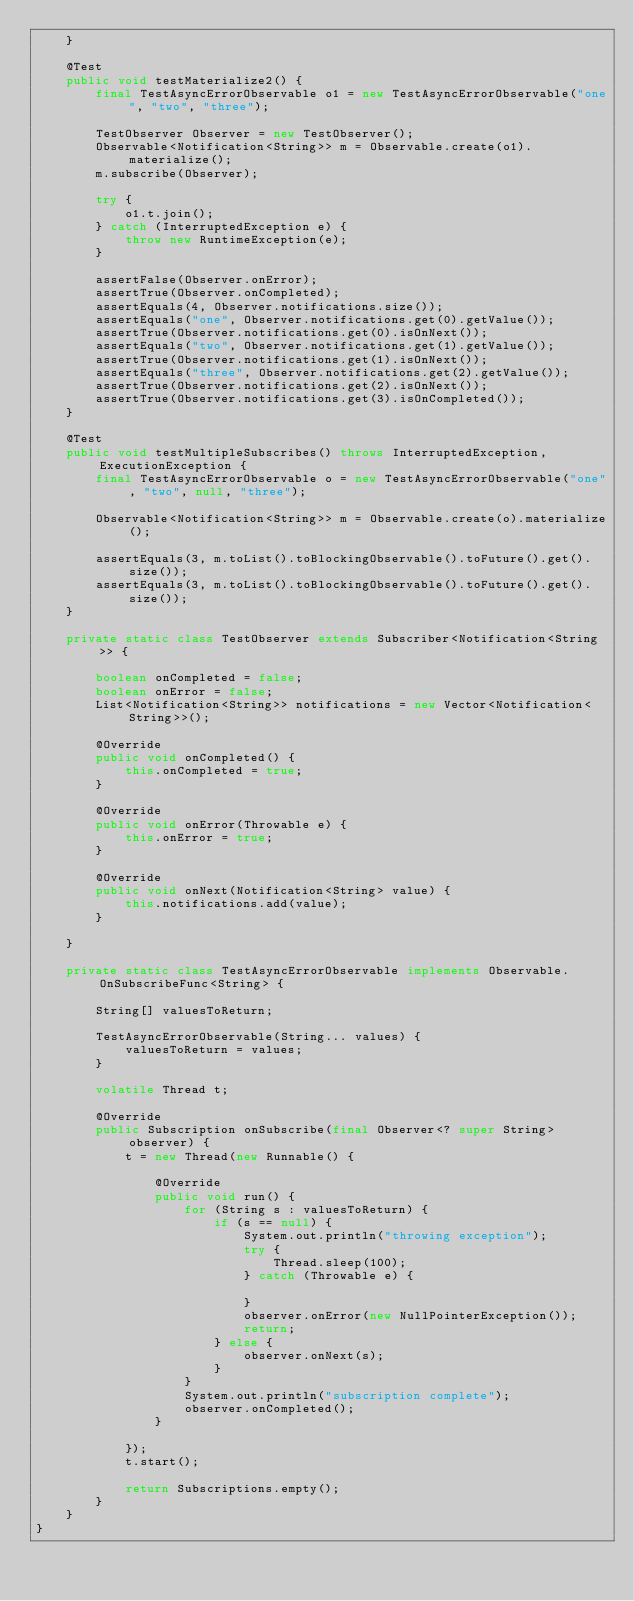Convert code to text. <code><loc_0><loc_0><loc_500><loc_500><_Java_>    }

    @Test
    public void testMaterialize2() {
        final TestAsyncErrorObservable o1 = new TestAsyncErrorObservable("one", "two", "three");

        TestObserver Observer = new TestObserver();
        Observable<Notification<String>> m = Observable.create(o1).materialize();
        m.subscribe(Observer);

        try {
            o1.t.join();
        } catch (InterruptedException e) {
            throw new RuntimeException(e);
        }

        assertFalse(Observer.onError);
        assertTrue(Observer.onCompleted);
        assertEquals(4, Observer.notifications.size());
        assertEquals("one", Observer.notifications.get(0).getValue());
        assertTrue(Observer.notifications.get(0).isOnNext());
        assertEquals("two", Observer.notifications.get(1).getValue());
        assertTrue(Observer.notifications.get(1).isOnNext());
        assertEquals("three", Observer.notifications.get(2).getValue());
        assertTrue(Observer.notifications.get(2).isOnNext());
        assertTrue(Observer.notifications.get(3).isOnCompleted());
    }

    @Test
    public void testMultipleSubscribes() throws InterruptedException, ExecutionException {
        final TestAsyncErrorObservable o = new TestAsyncErrorObservable("one", "two", null, "three");

        Observable<Notification<String>> m = Observable.create(o).materialize();

        assertEquals(3, m.toList().toBlockingObservable().toFuture().get().size());
        assertEquals(3, m.toList().toBlockingObservable().toFuture().get().size());
    }

    private static class TestObserver extends Subscriber<Notification<String>> {

        boolean onCompleted = false;
        boolean onError = false;
        List<Notification<String>> notifications = new Vector<Notification<String>>();

        @Override
        public void onCompleted() {
            this.onCompleted = true;
        }

        @Override
        public void onError(Throwable e) {
            this.onError = true;
        }

        @Override
        public void onNext(Notification<String> value) {
            this.notifications.add(value);
        }

    }

    private static class TestAsyncErrorObservable implements Observable.OnSubscribeFunc<String> {

        String[] valuesToReturn;

        TestAsyncErrorObservable(String... values) {
            valuesToReturn = values;
        }

        volatile Thread t;

        @Override
        public Subscription onSubscribe(final Observer<? super String> observer) {
            t = new Thread(new Runnable() {

                @Override
                public void run() {
                    for (String s : valuesToReturn) {
                        if (s == null) {
                            System.out.println("throwing exception");
                            try {
                                Thread.sleep(100);
                            } catch (Throwable e) {

                            }
                            observer.onError(new NullPointerException());
                            return;
                        } else {
                            observer.onNext(s);
                        }
                    }
                    System.out.println("subscription complete");
                    observer.onCompleted();
                }

            });
            t.start();

            return Subscriptions.empty();
        }
    }
}
</code> 